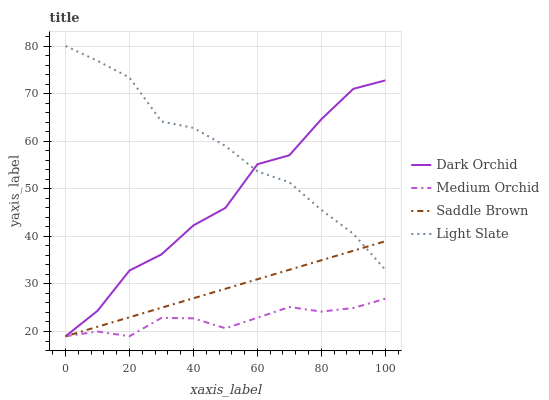Does Medium Orchid have the minimum area under the curve?
Answer yes or no. Yes. Does Light Slate have the maximum area under the curve?
Answer yes or no. Yes. Does Saddle Brown have the minimum area under the curve?
Answer yes or no. No. Does Saddle Brown have the maximum area under the curve?
Answer yes or no. No. Is Saddle Brown the smoothest?
Answer yes or no. Yes. Is Dark Orchid the roughest?
Answer yes or no. Yes. Is Medium Orchid the smoothest?
Answer yes or no. No. Is Medium Orchid the roughest?
Answer yes or no. No. Does Medium Orchid have the lowest value?
Answer yes or no. Yes. Does Light Slate have the highest value?
Answer yes or no. Yes. Does Saddle Brown have the highest value?
Answer yes or no. No. Is Medium Orchid less than Light Slate?
Answer yes or no. Yes. Is Light Slate greater than Medium Orchid?
Answer yes or no. Yes. Does Light Slate intersect Dark Orchid?
Answer yes or no. Yes. Is Light Slate less than Dark Orchid?
Answer yes or no. No. Is Light Slate greater than Dark Orchid?
Answer yes or no. No. Does Medium Orchid intersect Light Slate?
Answer yes or no. No. 